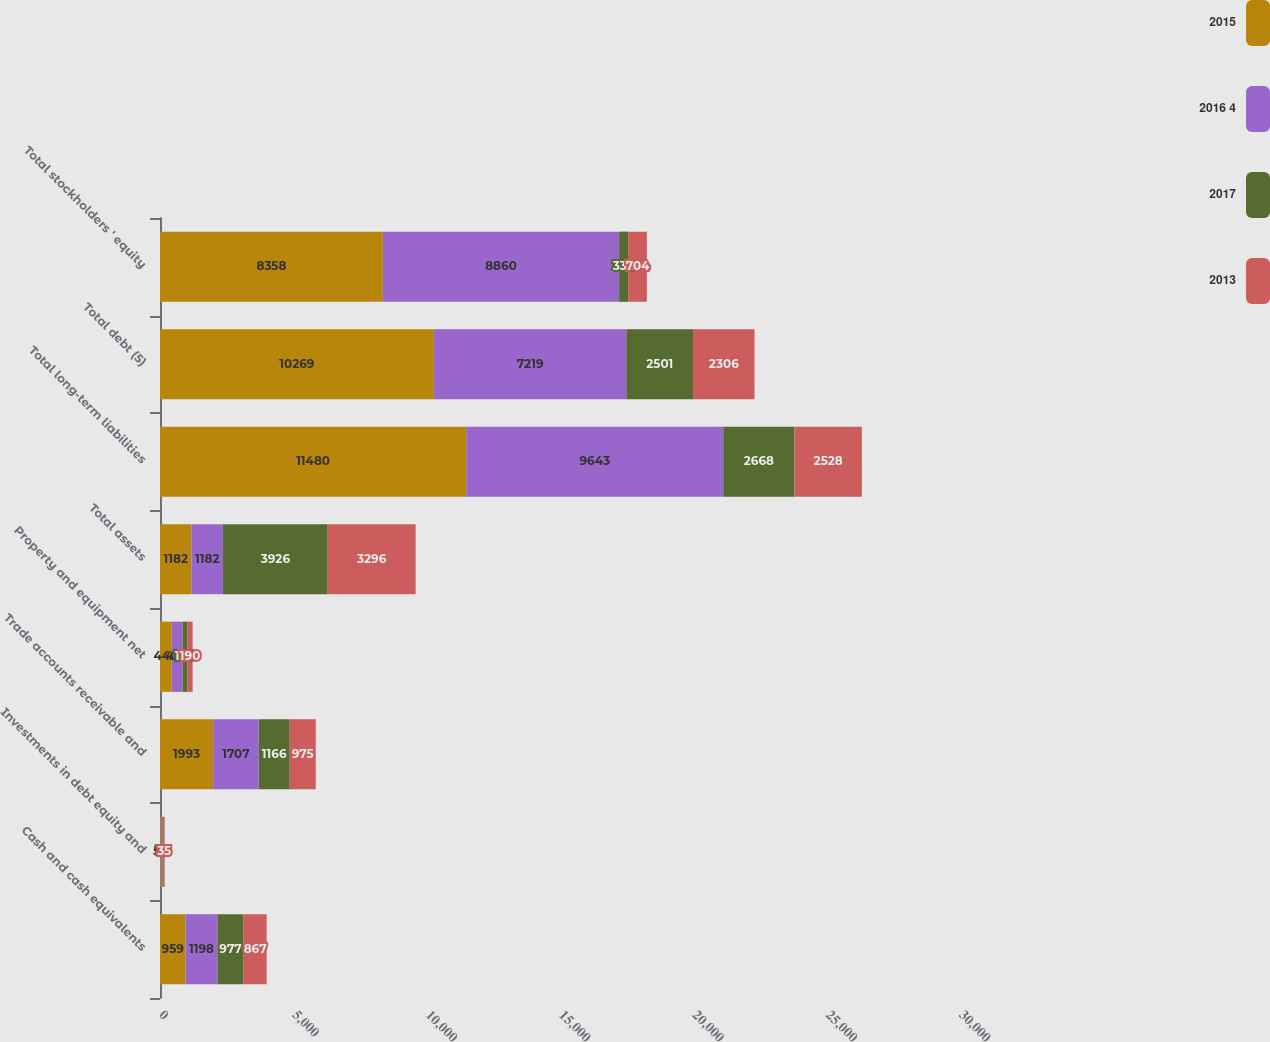<chart> <loc_0><loc_0><loc_500><loc_500><stacked_bar_chart><ecel><fcel>Cash and cash equivalents<fcel>Investments in debt equity and<fcel>Trade accounts receivable and<fcel>Property and equipment net<fcel>Total assets<fcel>Total long-term liabilities<fcel>Total debt (5)<fcel>Total stockholders ' equity<nl><fcel>2015<fcel>959<fcel>54<fcel>1993<fcel>440<fcel>1182<fcel>11480<fcel>10269<fcel>8358<nl><fcel>2016 4<fcel>1198<fcel>53<fcel>1707<fcel>406<fcel>1182<fcel>9643<fcel>7219<fcel>8860<nl><fcel>2017<fcel>977<fcel>33<fcel>1166<fcel>188<fcel>3926<fcel>2668<fcel>2501<fcel>336<nl><fcel>2013<fcel>867<fcel>35<fcel>975<fcel>190<fcel>3296<fcel>2528<fcel>2306<fcel>704<nl></chart> 